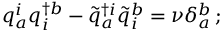Convert formula to latex. <formula><loc_0><loc_0><loc_500><loc_500>q _ { a } ^ { i } q _ { i } ^ { \dagger b } - { \tilde { q } } _ { a } ^ { \dagger i } { \tilde { q } } _ { i } ^ { b } = \nu \delta _ { a } ^ { b } \, ;</formula> 